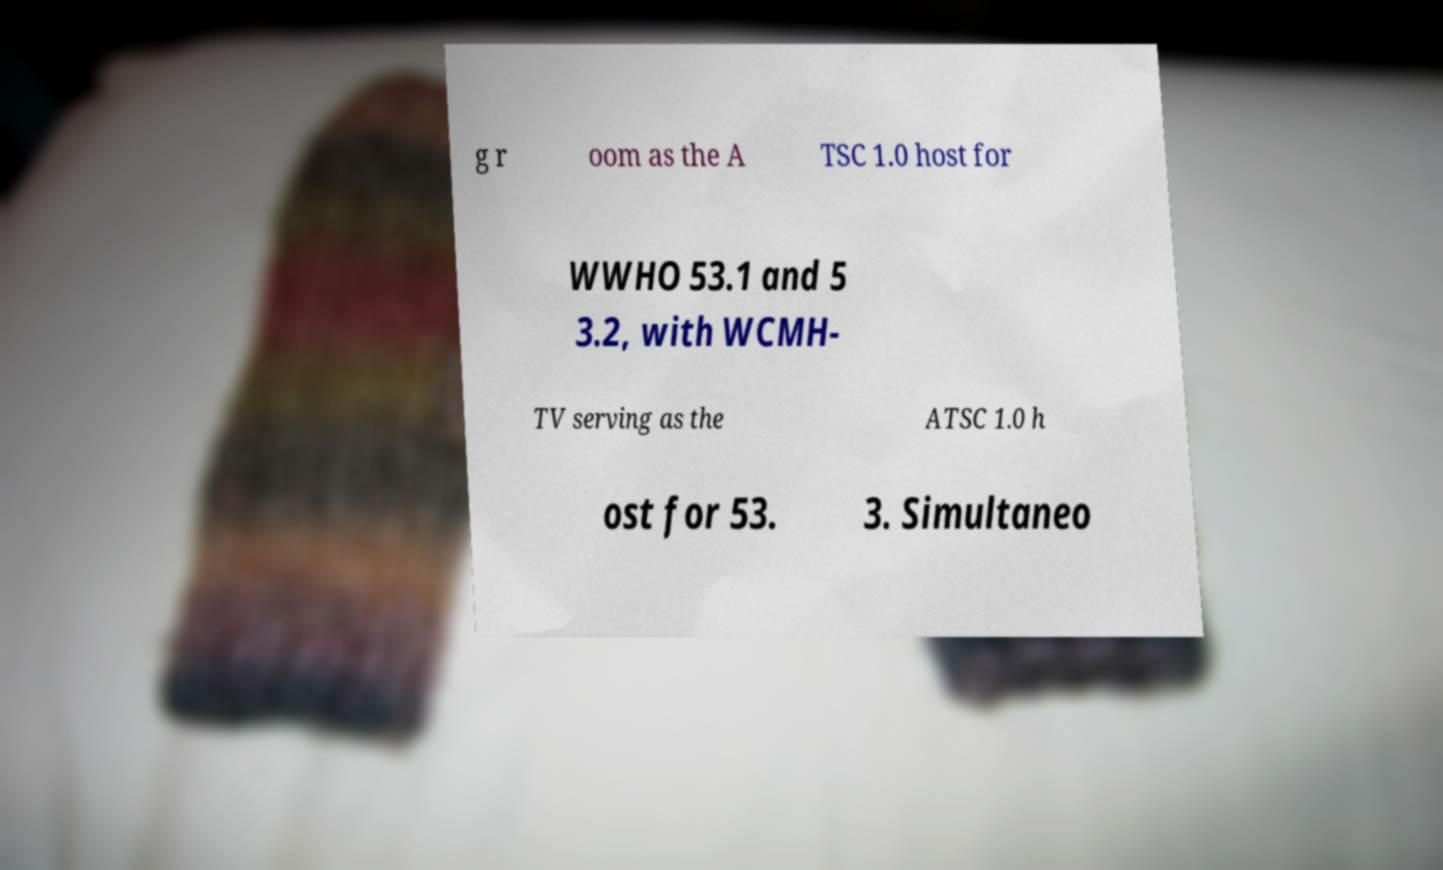What messages or text are displayed in this image? I need them in a readable, typed format. g r oom as the A TSC 1.0 host for WWHO 53.1 and 5 3.2, with WCMH- TV serving as the ATSC 1.0 h ost for 53. 3. Simultaneo 